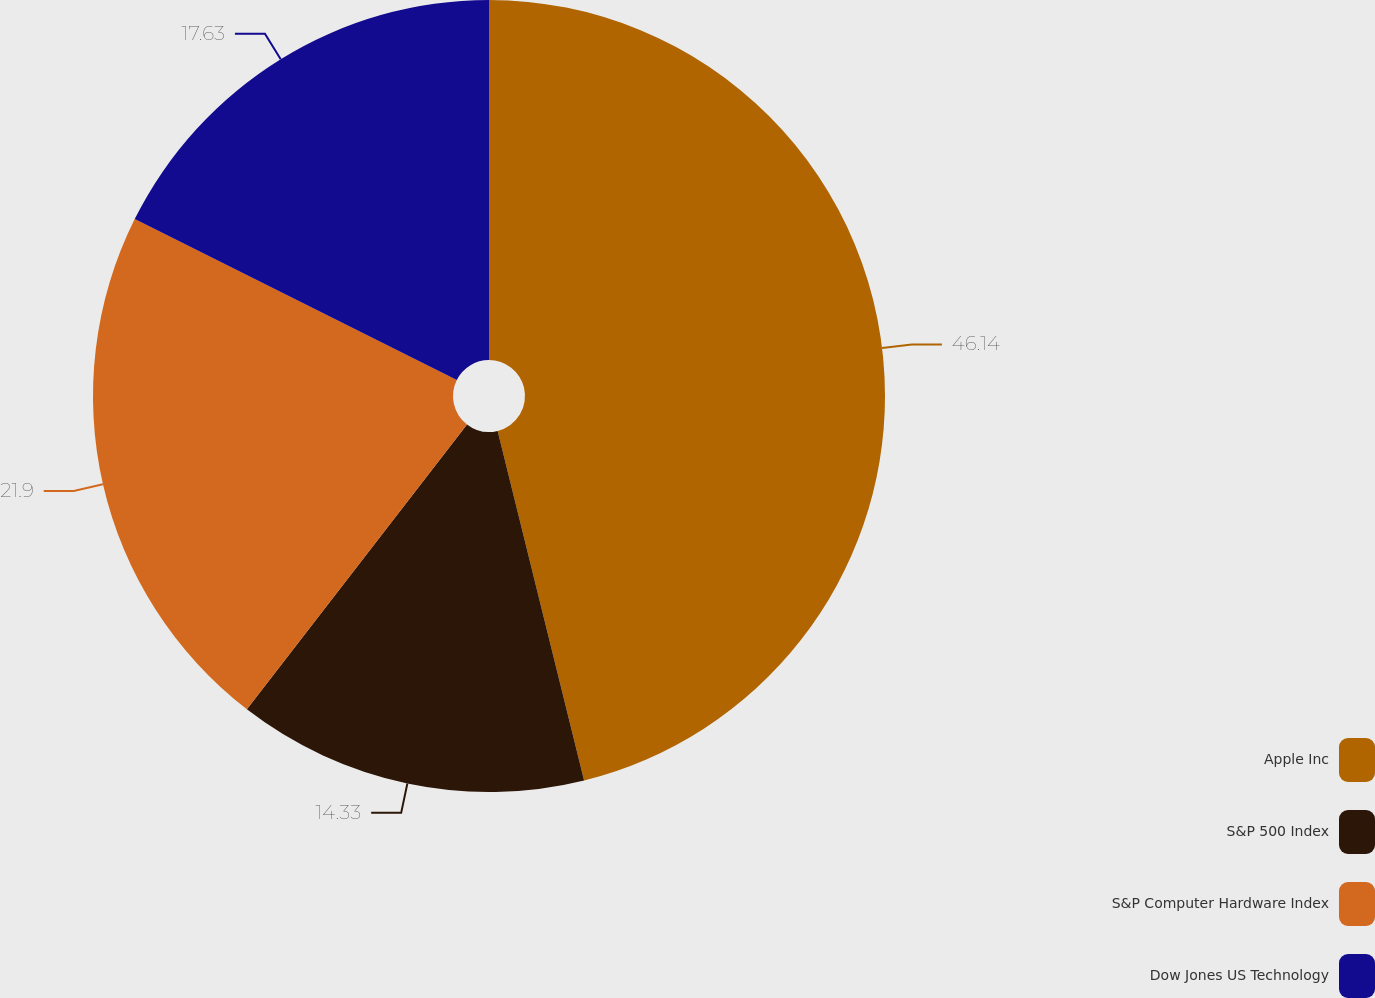Convert chart. <chart><loc_0><loc_0><loc_500><loc_500><pie_chart><fcel>Apple Inc<fcel>S&P 500 Index<fcel>S&P Computer Hardware Index<fcel>Dow Jones US Technology<nl><fcel>46.14%<fcel>14.33%<fcel>21.9%<fcel>17.63%<nl></chart> 